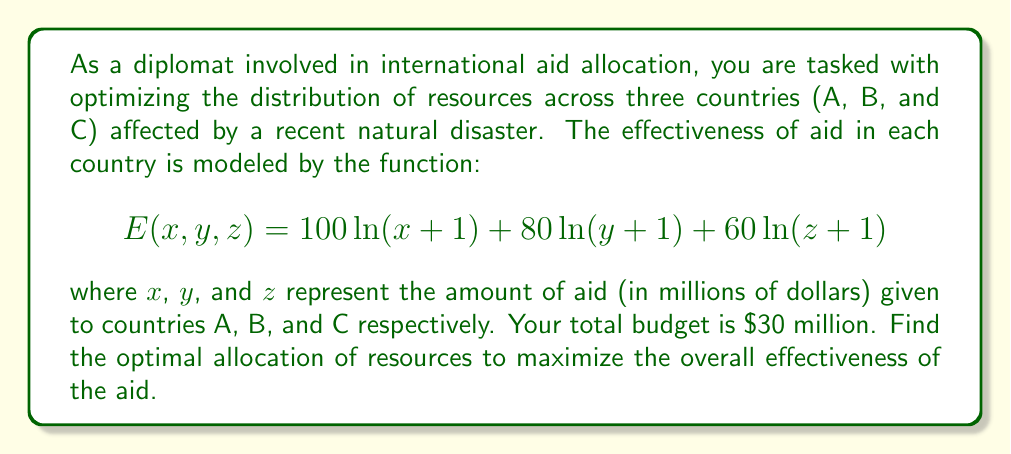Could you help me with this problem? To solve this optimization problem, we'll use the method of Lagrange multipliers:

1) First, we set up the Lagrangian function:
   $$L(x,y,z,\lambda) = 100\ln(x+1) + 80\ln(y+1) + 60\ln(z+1) - \lambda(x+y+z-30)$$

2) Now, we take partial derivatives and set them equal to zero:

   $$\frac{\partial L}{\partial x} = \frac{100}{x+1} - \lambda = 0$$
   $$\frac{\partial L}{\partial y} = \frac{80}{y+1} - \lambda = 0$$
   $$\frac{\partial L}{\partial z} = \frac{60}{z+1} - \lambda = 0$$
   $$\frac{\partial L}{\partial \lambda} = x + y + z - 30 = 0$$

3) From the first three equations:
   $$\frac{100}{x+1} = \frac{80}{y+1} = \frac{60}{z+1} = \lambda$$

4) This implies:
   $$x+1 = \frac{100}{\lambda}, y+1 = \frac{80}{\lambda}, z+1 = \frac{60}{\lambda}$$

5) Substituting into the budget constraint:
   $$(\frac{100}{\lambda}-1) + (\frac{80}{\lambda}-1) + (\frac{60}{\lambda}-1) = 30$$
   $$\frac{240}{\lambda} - 3 = 30$$
   $$\frac{240}{\lambda} = 33$$
   $$\lambda = \frac{240}{33}$$

6) Now we can solve for x, y, and z:
   $$x = \frac{100}{\lambda} - 1 = \frac{100 \cdot 33}{240} - 1 = \frac{330}{24} - 1 = \frac{165}{12} - 1 = \frac{153}{12} = 12.75$$
   $$y = \frac{80}{\lambda} - 1 = \frac{80 \cdot 33}{240} - 1 = \frac{264}{24} - 1 = 10$$
   $$z = \frac{60}{\lambda} - 1 = \frac{60 \cdot 33}{240} - 1 = \frac{198}{24} - 1 = \frac{174}{24} - 1 = \frac{150}{24} = 6.25$$

7) We can verify that these values sum to 30, satisfying our budget constraint.
Answer: The optimal allocation of resources is:
Country A: $12.75 million
Country B: $10 million
Country C: $6.25 million 